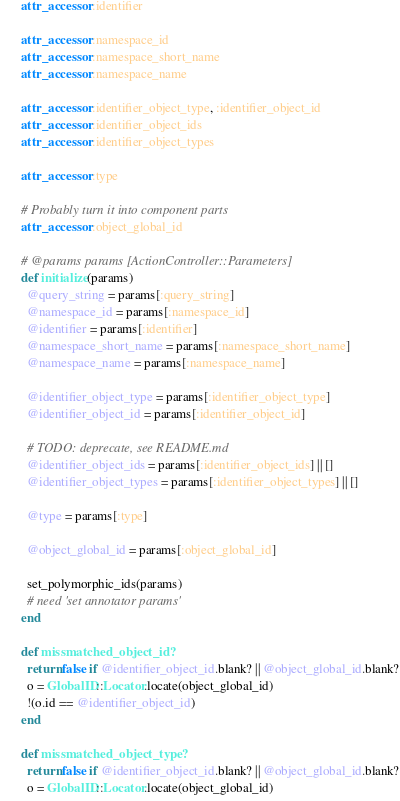Convert code to text. <code><loc_0><loc_0><loc_500><loc_500><_Ruby_>      attr_accessor :identifier

      attr_accessor :namespace_id
      attr_accessor :namespace_short_name
      attr_accessor :namespace_name

      attr_accessor :identifier_object_type, :identifier_object_id 
      attr_accessor :identifier_object_ids
      attr_accessor :identifier_object_types

      attr_accessor :type

      # Probably turn it into component parts
      attr_accessor :object_global_id

      # @params params [ActionController::Parameters]
      def initialize(params)
        @query_string = params[:query_string]
        @namespace_id = params[:namespace_id]
        @identifier = params[:identifier]
        @namespace_short_name = params[:namespace_short_name]
        @namespace_name = params[:namespace_name]

        @identifier_object_type = params[:identifier_object_type] 
        @identifier_object_id = params[:identifier_object_id] 

        # TODO: deprecate, see README.md
        @identifier_object_ids = params[:identifier_object_ids] || []
        @identifier_object_types = params[:identifier_object_types] || []

        @type = params[:type]

        @object_global_id = params[:object_global_id]

        set_polymorphic_ids(params)
        # need 'set annotator params'
      end

      def missmatched_object_id?
        return false if @identifier_object_id.blank? || @object_global_id.blank?
        o = GlobalID::Locator.locate(object_global_id)
        !(o.id == @identifier_object_id)
      end

      def missmatched_object_type?
        return false if @identifier_object_id.blank? || @object_global_id.blank?
        o = GlobalID::Locator.locate(object_global_id)</code> 